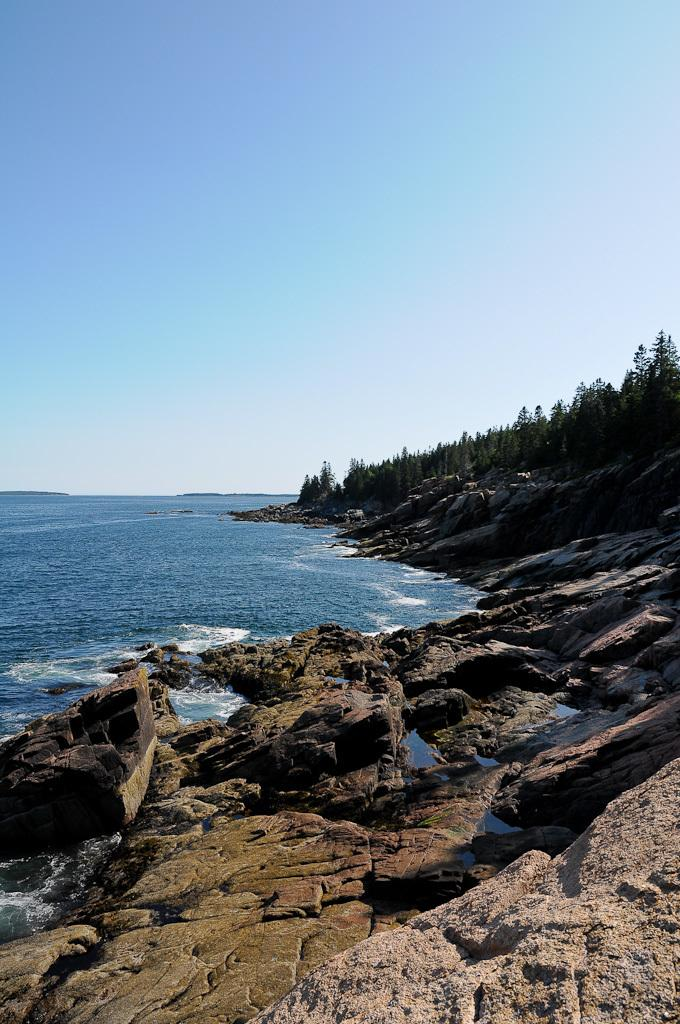What type of natural feature is located on the left side of the image? There is an ocean on the left side of the image. What type of vegetation is on the right side of the image? There are many trees on the right side of the image. What can be seen at the bottom of the image? There are stones visible at the bottom of the image. What is visible at the top of the image? The sky is visible at the top of the image. How many baskets are being carried by the servant in the image? There are no baskets or servants present in the image. What type of experience can be gained from observing the image? The image does not depict an experience; it is a static representation of an ocean, trees, stones, and the sky. 